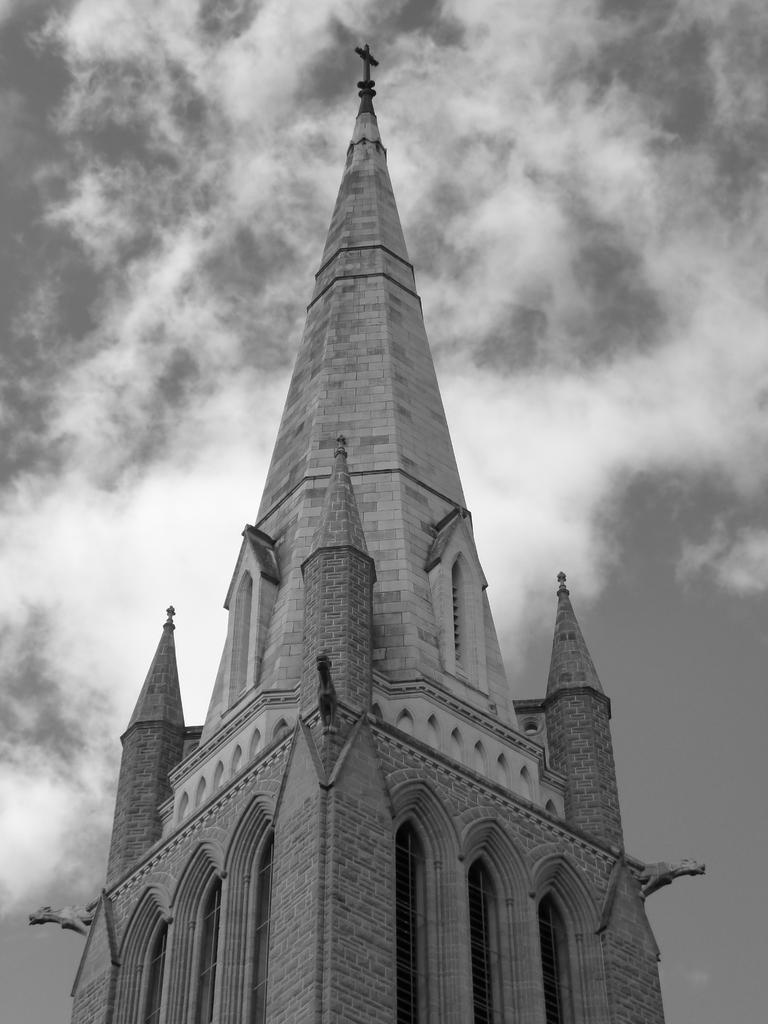What is the color scheme of the image? The image is black and white. What type of building can be seen in the image? There is a building with a cross in the image. What is visible in the background of the image? The sky is visible in the image. How would you describe the sky in the image? The sky appears cloudy in the image. How many fingers can be seen pointing at the building in the image? There are no fingers visible in the image, so it is not possible to determine how many fingers might be pointing at the building. 